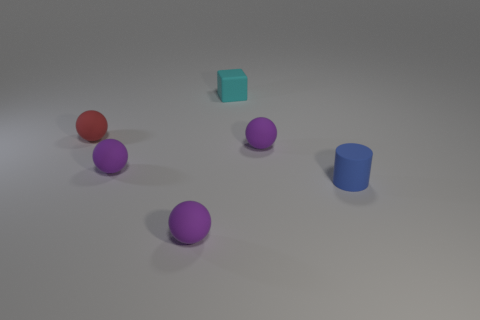Subtract all yellow blocks. How many purple spheres are left? 3 Add 4 cyan rubber cubes. How many objects exist? 10 Subtract all balls. How many objects are left? 2 Subtract all big green shiny cylinders. Subtract all small blocks. How many objects are left? 5 Add 2 tiny blue matte objects. How many tiny blue matte objects are left? 3 Add 4 tiny blue things. How many tiny blue things exist? 5 Subtract 0 green cylinders. How many objects are left? 6 